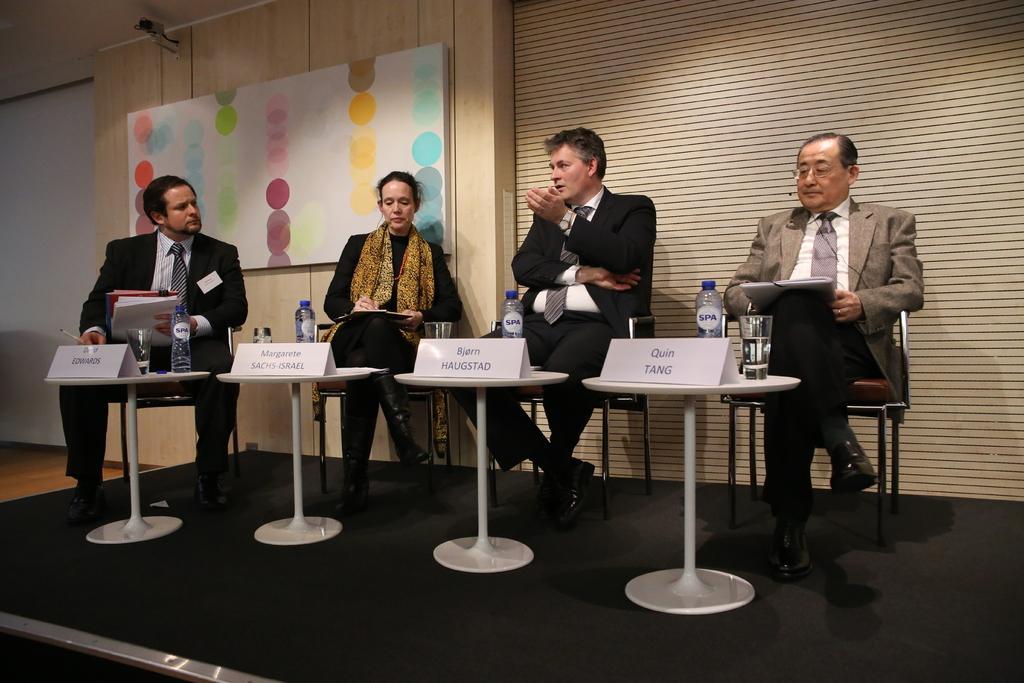Please provide a concise description of this image. This picture is of inside including tables, chairs and a group of people. There is a bottle, glass of water and a name plate placed on the top of the table. In the center there is a Man sitting on a chair and talking and there are group of people sitting on the chairs and in the background there is a wall mounted camera and a board. 